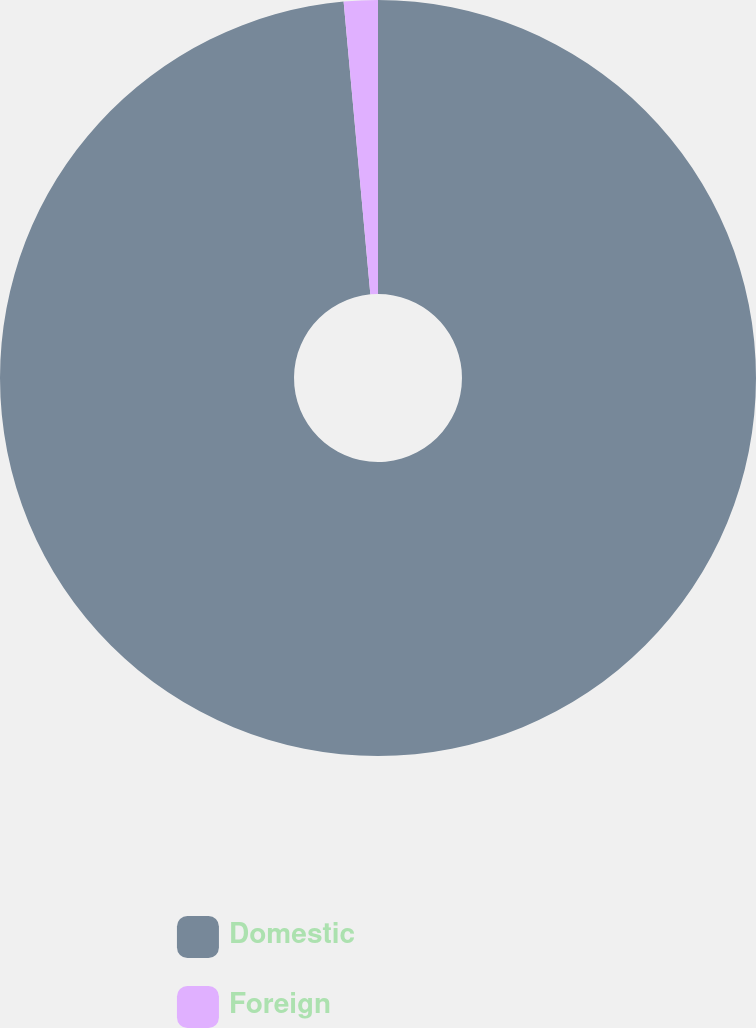Convert chart. <chart><loc_0><loc_0><loc_500><loc_500><pie_chart><fcel>Domestic<fcel>Foreign<nl><fcel>98.55%<fcel>1.45%<nl></chart> 